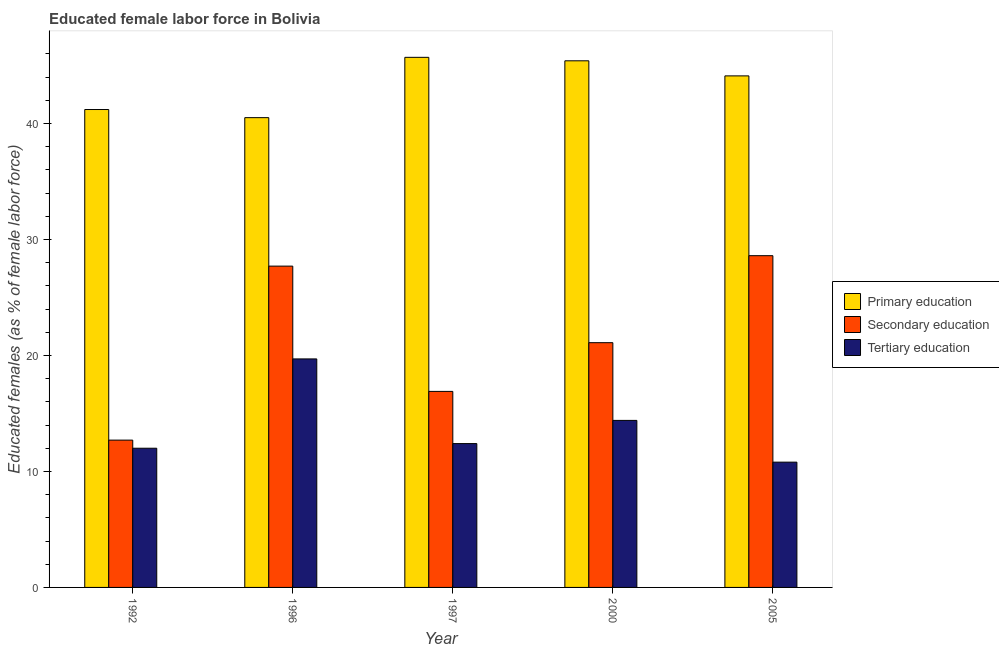How many different coloured bars are there?
Offer a terse response. 3. What is the label of the 3rd group of bars from the left?
Your answer should be very brief. 1997. In how many cases, is the number of bars for a given year not equal to the number of legend labels?
Your response must be concise. 0. What is the percentage of female labor force who received secondary education in 1997?
Your answer should be compact. 16.9. Across all years, what is the maximum percentage of female labor force who received primary education?
Ensure brevity in your answer.  45.7. Across all years, what is the minimum percentage of female labor force who received secondary education?
Give a very brief answer. 12.7. In which year was the percentage of female labor force who received primary education maximum?
Your answer should be very brief. 1997. In which year was the percentage of female labor force who received tertiary education minimum?
Provide a succinct answer. 2005. What is the total percentage of female labor force who received tertiary education in the graph?
Ensure brevity in your answer.  69.3. What is the difference between the percentage of female labor force who received tertiary education in 1996 and that in 2005?
Offer a very short reply. 8.9. What is the difference between the percentage of female labor force who received tertiary education in 2000 and the percentage of female labor force who received primary education in 2005?
Provide a short and direct response. 3.6. What is the average percentage of female labor force who received primary education per year?
Offer a terse response. 43.38. What is the ratio of the percentage of female labor force who received secondary education in 1996 to that in 1997?
Provide a succinct answer. 1.64. Is the difference between the percentage of female labor force who received primary education in 1996 and 2000 greater than the difference between the percentage of female labor force who received tertiary education in 1996 and 2000?
Offer a terse response. No. What is the difference between the highest and the second highest percentage of female labor force who received tertiary education?
Keep it short and to the point. 5.3. What is the difference between the highest and the lowest percentage of female labor force who received primary education?
Provide a succinct answer. 5.2. Is the sum of the percentage of female labor force who received tertiary education in 1997 and 2000 greater than the maximum percentage of female labor force who received primary education across all years?
Offer a very short reply. Yes. What does the 1st bar from the left in 2000 represents?
Offer a very short reply. Primary education. What does the 3rd bar from the right in 2005 represents?
Provide a short and direct response. Primary education. How many bars are there?
Your answer should be very brief. 15. Are the values on the major ticks of Y-axis written in scientific E-notation?
Your response must be concise. No. Does the graph contain any zero values?
Ensure brevity in your answer.  No. How are the legend labels stacked?
Provide a short and direct response. Vertical. What is the title of the graph?
Make the answer very short. Educated female labor force in Bolivia. Does "Machinery" appear as one of the legend labels in the graph?
Keep it short and to the point. No. What is the label or title of the X-axis?
Make the answer very short. Year. What is the label or title of the Y-axis?
Give a very brief answer. Educated females (as % of female labor force). What is the Educated females (as % of female labor force) in Primary education in 1992?
Ensure brevity in your answer.  41.2. What is the Educated females (as % of female labor force) of Secondary education in 1992?
Give a very brief answer. 12.7. What is the Educated females (as % of female labor force) in Tertiary education in 1992?
Your answer should be very brief. 12. What is the Educated females (as % of female labor force) of Primary education in 1996?
Offer a terse response. 40.5. What is the Educated females (as % of female labor force) of Secondary education in 1996?
Make the answer very short. 27.7. What is the Educated females (as % of female labor force) in Tertiary education in 1996?
Provide a short and direct response. 19.7. What is the Educated females (as % of female labor force) of Primary education in 1997?
Your response must be concise. 45.7. What is the Educated females (as % of female labor force) of Secondary education in 1997?
Provide a succinct answer. 16.9. What is the Educated females (as % of female labor force) in Tertiary education in 1997?
Your answer should be very brief. 12.4. What is the Educated females (as % of female labor force) in Primary education in 2000?
Provide a short and direct response. 45.4. What is the Educated females (as % of female labor force) of Secondary education in 2000?
Ensure brevity in your answer.  21.1. What is the Educated females (as % of female labor force) in Tertiary education in 2000?
Offer a terse response. 14.4. What is the Educated females (as % of female labor force) of Primary education in 2005?
Offer a terse response. 44.1. What is the Educated females (as % of female labor force) in Secondary education in 2005?
Ensure brevity in your answer.  28.6. What is the Educated females (as % of female labor force) in Tertiary education in 2005?
Keep it short and to the point. 10.8. Across all years, what is the maximum Educated females (as % of female labor force) in Primary education?
Ensure brevity in your answer.  45.7. Across all years, what is the maximum Educated females (as % of female labor force) of Secondary education?
Your response must be concise. 28.6. Across all years, what is the maximum Educated females (as % of female labor force) of Tertiary education?
Provide a succinct answer. 19.7. Across all years, what is the minimum Educated females (as % of female labor force) of Primary education?
Offer a terse response. 40.5. Across all years, what is the minimum Educated females (as % of female labor force) of Secondary education?
Your answer should be very brief. 12.7. Across all years, what is the minimum Educated females (as % of female labor force) in Tertiary education?
Your response must be concise. 10.8. What is the total Educated females (as % of female labor force) in Primary education in the graph?
Offer a terse response. 216.9. What is the total Educated females (as % of female labor force) in Secondary education in the graph?
Provide a succinct answer. 107. What is the total Educated females (as % of female labor force) in Tertiary education in the graph?
Give a very brief answer. 69.3. What is the difference between the Educated females (as % of female labor force) of Primary education in 1992 and that in 1996?
Your answer should be compact. 0.7. What is the difference between the Educated females (as % of female labor force) of Secondary education in 1992 and that in 1996?
Your answer should be compact. -15. What is the difference between the Educated females (as % of female labor force) in Tertiary education in 1992 and that in 1996?
Offer a terse response. -7.7. What is the difference between the Educated females (as % of female labor force) of Tertiary education in 1992 and that in 1997?
Keep it short and to the point. -0.4. What is the difference between the Educated females (as % of female labor force) in Primary education in 1992 and that in 2000?
Make the answer very short. -4.2. What is the difference between the Educated females (as % of female labor force) in Secondary education in 1992 and that in 2005?
Ensure brevity in your answer.  -15.9. What is the difference between the Educated females (as % of female labor force) in Primary education in 1996 and that in 1997?
Provide a succinct answer. -5.2. What is the difference between the Educated females (as % of female labor force) of Secondary education in 1996 and that in 1997?
Provide a succinct answer. 10.8. What is the difference between the Educated females (as % of female labor force) of Secondary education in 1996 and that in 2000?
Keep it short and to the point. 6.6. What is the difference between the Educated females (as % of female labor force) of Tertiary education in 1996 and that in 2000?
Offer a terse response. 5.3. What is the difference between the Educated females (as % of female labor force) of Primary education in 1996 and that in 2005?
Give a very brief answer. -3.6. What is the difference between the Educated females (as % of female labor force) of Tertiary education in 1996 and that in 2005?
Give a very brief answer. 8.9. What is the difference between the Educated females (as % of female labor force) in Tertiary education in 1997 and that in 2000?
Provide a short and direct response. -2. What is the difference between the Educated females (as % of female labor force) in Secondary education in 1997 and that in 2005?
Your answer should be compact. -11.7. What is the difference between the Educated females (as % of female labor force) of Primary education in 2000 and that in 2005?
Keep it short and to the point. 1.3. What is the difference between the Educated females (as % of female labor force) of Primary education in 1992 and the Educated females (as % of female labor force) of Secondary education in 1996?
Keep it short and to the point. 13.5. What is the difference between the Educated females (as % of female labor force) of Primary education in 1992 and the Educated females (as % of female labor force) of Secondary education in 1997?
Your answer should be compact. 24.3. What is the difference between the Educated females (as % of female labor force) in Primary education in 1992 and the Educated females (as % of female labor force) in Tertiary education in 1997?
Give a very brief answer. 28.8. What is the difference between the Educated females (as % of female labor force) of Primary education in 1992 and the Educated females (as % of female labor force) of Secondary education in 2000?
Make the answer very short. 20.1. What is the difference between the Educated females (as % of female labor force) of Primary education in 1992 and the Educated females (as % of female labor force) of Tertiary education in 2000?
Offer a very short reply. 26.8. What is the difference between the Educated females (as % of female labor force) of Secondary education in 1992 and the Educated females (as % of female labor force) of Tertiary education in 2000?
Provide a short and direct response. -1.7. What is the difference between the Educated females (as % of female labor force) of Primary education in 1992 and the Educated females (as % of female labor force) of Secondary education in 2005?
Give a very brief answer. 12.6. What is the difference between the Educated females (as % of female labor force) of Primary education in 1992 and the Educated females (as % of female labor force) of Tertiary education in 2005?
Give a very brief answer. 30.4. What is the difference between the Educated females (as % of female labor force) of Primary education in 1996 and the Educated females (as % of female labor force) of Secondary education in 1997?
Give a very brief answer. 23.6. What is the difference between the Educated females (as % of female labor force) in Primary education in 1996 and the Educated females (as % of female labor force) in Tertiary education in 1997?
Give a very brief answer. 28.1. What is the difference between the Educated females (as % of female labor force) of Secondary education in 1996 and the Educated females (as % of female labor force) of Tertiary education in 1997?
Provide a succinct answer. 15.3. What is the difference between the Educated females (as % of female labor force) of Primary education in 1996 and the Educated females (as % of female labor force) of Tertiary education in 2000?
Provide a short and direct response. 26.1. What is the difference between the Educated females (as % of female labor force) of Primary education in 1996 and the Educated females (as % of female labor force) of Secondary education in 2005?
Offer a very short reply. 11.9. What is the difference between the Educated females (as % of female labor force) in Primary education in 1996 and the Educated females (as % of female labor force) in Tertiary education in 2005?
Give a very brief answer. 29.7. What is the difference between the Educated females (as % of female labor force) in Secondary education in 1996 and the Educated females (as % of female labor force) in Tertiary education in 2005?
Provide a short and direct response. 16.9. What is the difference between the Educated females (as % of female labor force) in Primary education in 1997 and the Educated females (as % of female labor force) in Secondary education in 2000?
Offer a terse response. 24.6. What is the difference between the Educated females (as % of female labor force) in Primary education in 1997 and the Educated females (as % of female labor force) in Tertiary education in 2000?
Offer a very short reply. 31.3. What is the difference between the Educated females (as % of female labor force) in Secondary education in 1997 and the Educated females (as % of female labor force) in Tertiary education in 2000?
Keep it short and to the point. 2.5. What is the difference between the Educated females (as % of female labor force) in Primary education in 1997 and the Educated females (as % of female labor force) in Tertiary education in 2005?
Your answer should be very brief. 34.9. What is the difference between the Educated females (as % of female labor force) of Primary education in 2000 and the Educated females (as % of female labor force) of Secondary education in 2005?
Make the answer very short. 16.8. What is the difference between the Educated females (as % of female labor force) of Primary education in 2000 and the Educated females (as % of female labor force) of Tertiary education in 2005?
Your response must be concise. 34.6. What is the difference between the Educated females (as % of female labor force) of Secondary education in 2000 and the Educated females (as % of female labor force) of Tertiary education in 2005?
Make the answer very short. 10.3. What is the average Educated females (as % of female labor force) in Primary education per year?
Keep it short and to the point. 43.38. What is the average Educated females (as % of female labor force) in Secondary education per year?
Give a very brief answer. 21.4. What is the average Educated females (as % of female labor force) of Tertiary education per year?
Your response must be concise. 13.86. In the year 1992, what is the difference between the Educated females (as % of female labor force) of Primary education and Educated females (as % of female labor force) of Tertiary education?
Your answer should be compact. 29.2. In the year 1996, what is the difference between the Educated females (as % of female labor force) in Primary education and Educated females (as % of female labor force) in Secondary education?
Provide a short and direct response. 12.8. In the year 1996, what is the difference between the Educated females (as % of female labor force) in Primary education and Educated females (as % of female labor force) in Tertiary education?
Your response must be concise. 20.8. In the year 1996, what is the difference between the Educated females (as % of female labor force) of Secondary education and Educated females (as % of female labor force) of Tertiary education?
Offer a very short reply. 8. In the year 1997, what is the difference between the Educated females (as % of female labor force) in Primary education and Educated females (as % of female labor force) in Secondary education?
Your answer should be compact. 28.8. In the year 1997, what is the difference between the Educated females (as % of female labor force) in Primary education and Educated females (as % of female labor force) in Tertiary education?
Your response must be concise. 33.3. In the year 1997, what is the difference between the Educated females (as % of female labor force) in Secondary education and Educated females (as % of female labor force) in Tertiary education?
Your answer should be very brief. 4.5. In the year 2000, what is the difference between the Educated females (as % of female labor force) in Primary education and Educated females (as % of female labor force) in Secondary education?
Provide a succinct answer. 24.3. In the year 2000, what is the difference between the Educated females (as % of female labor force) in Secondary education and Educated females (as % of female labor force) in Tertiary education?
Offer a very short reply. 6.7. In the year 2005, what is the difference between the Educated females (as % of female labor force) in Primary education and Educated females (as % of female labor force) in Secondary education?
Give a very brief answer. 15.5. In the year 2005, what is the difference between the Educated females (as % of female labor force) in Primary education and Educated females (as % of female labor force) in Tertiary education?
Give a very brief answer. 33.3. In the year 2005, what is the difference between the Educated females (as % of female labor force) of Secondary education and Educated females (as % of female labor force) of Tertiary education?
Offer a very short reply. 17.8. What is the ratio of the Educated females (as % of female labor force) of Primary education in 1992 to that in 1996?
Your answer should be compact. 1.02. What is the ratio of the Educated females (as % of female labor force) in Secondary education in 1992 to that in 1996?
Your answer should be compact. 0.46. What is the ratio of the Educated females (as % of female labor force) in Tertiary education in 1992 to that in 1996?
Your answer should be very brief. 0.61. What is the ratio of the Educated females (as % of female labor force) in Primary education in 1992 to that in 1997?
Keep it short and to the point. 0.9. What is the ratio of the Educated females (as % of female labor force) of Secondary education in 1992 to that in 1997?
Give a very brief answer. 0.75. What is the ratio of the Educated females (as % of female labor force) in Primary education in 1992 to that in 2000?
Offer a very short reply. 0.91. What is the ratio of the Educated females (as % of female labor force) in Secondary education in 1992 to that in 2000?
Provide a succinct answer. 0.6. What is the ratio of the Educated females (as % of female labor force) in Primary education in 1992 to that in 2005?
Your answer should be compact. 0.93. What is the ratio of the Educated females (as % of female labor force) of Secondary education in 1992 to that in 2005?
Your answer should be very brief. 0.44. What is the ratio of the Educated females (as % of female labor force) of Tertiary education in 1992 to that in 2005?
Make the answer very short. 1.11. What is the ratio of the Educated females (as % of female labor force) in Primary education in 1996 to that in 1997?
Provide a succinct answer. 0.89. What is the ratio of the Educated females (as % of female labor force) of Secondary education in 1996 to that in 1997?
Your answer should be very brief. 1.64. What is the ratio of the Educated females (as % of female labor force) in Tertiary education in 1996 to that in 1997?
Keep it short and to the point. 1.59. What is the ratio of the Educated females (as % of female labor force) in Primary education in 1996 to that in 2000?
Make the answer very short. 0.89. What is the ratio of the Educated females (as % of female labor force) in Secondary education in 1996 to that in 2000?
Offer a terse response. 1.31. What is the ratio of the Educated females (as % of female labor force) in Tertiary education in 1996 to that in 2000?
Offer a terse response. 1.37. What is the ratio of the Educated females (as % of female labor force) of Primary education in 1996 to that in 2005?
Offer a terse response. 0.92. What is the ratio of the Educated females (as % of female labor force) in Secondary education in 1996 to that in 2005?
Provide a succinct answer. 0.97. What is the ratio of the Educated females (as % of female labor force) in Tertiary education in 1996 to that in 2005?
Ensure brevity in your answer.  1.82. What is the ratio of the Educated females (as % of female labor force) of Primary education in 1997 to that in 2000?
Provide a short and direct response. 1.01. What is the ratio of the Educated females (as % of female labor force) in Secondary education in 1997 to that in 2000?
Your answer should be compact. 0.8. What is the ratio of the Educated females (as % of female labor force) of Tertiary education in 1997 to that in 2000?
Your answer should be very brief. 0.86. What is the ratio of the Educated females (as % of female labor force) of Primary education in 1997 to that in 2005?
Your response must be concise. 1.04. What is the ratio of the Educated females (as % of female labor force) of Secondary education in 1997 to that in 2005?
Give a very brief answer. 0.59. What is the ratio of the Educated females (as % of female labor force) of Tertiary education in 1997 to that in 2005?
Ensure brevity in your answer.  1.15. What is the ratio of the Educated females (as % of female labor force) of Primary education in 2000 to that in 2005?
Provide a short and direct response. 1.03. What is the ratio of the Educated females (as % of female labor force) in Secondary education in 2000 to that in 2005?
Provide a succinct answer. 0.74. What is the difference between the highest and the second highest Educated females (as % of female labor force) of Secondary education?
Offer a very short reply. 0.9. What is the difference between the highest and the lowest Educated females (as % of female labor force) of Primary education?
Keep it short and to the point. 5.2. What is the difference between the highest and the lowest Educated females (as % of female labor force) of Secondary education?
Your answer should be compact. 15.9. What is the difference between the highest and the lowest Educated females (as % of female labor force) in Tertiary education?
Your answer should be compact. 8.9. 